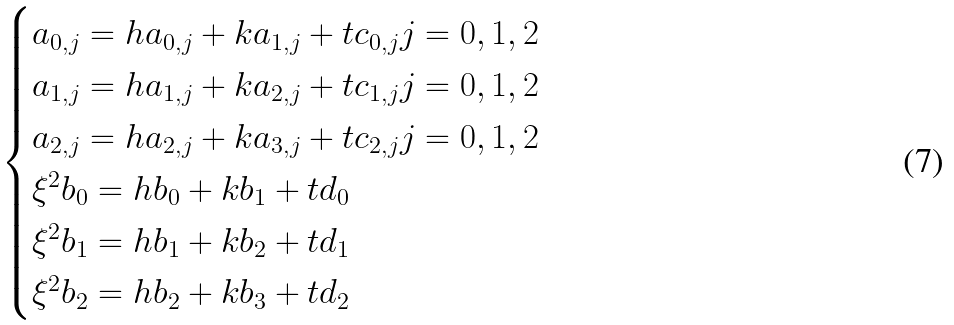Convert formula to latex. <formula><loc_0><loc_0><loc_500><loc_500>\begin{cases} a _ { 0 , j } = h a _ { 0 , j } + k a _ { 1 , j } + t c _ { 0 , j } j = 0 , 1 , 2 \\ a _ { 1 , j } = h a _ { 1 , j } + k a _ { 2 , j } + t c _ { 1 , j } j = 0 , 1 , 2 \\ a _ { 2 , j } = h a _ { 2 , j } + k a _ { 3 , j } + t c _ { 2 , j } j = 0 , 1 , 2 \\ \xi ^ { 2 } b _ { 0 } = h b _ { 0 } + k b _ { 1 } + t d _ { 0 } \\ \xi ^ { 2 } b _ { 1 } = h b _ { 1 } + k b _ { 2 } + t d _ { 1 } \\ \xi ^ { 2 } b _ { 2 } = h b _ { 2 } + k b _ { 3 } + t d _ { 2 } \end{cases}</formula> 